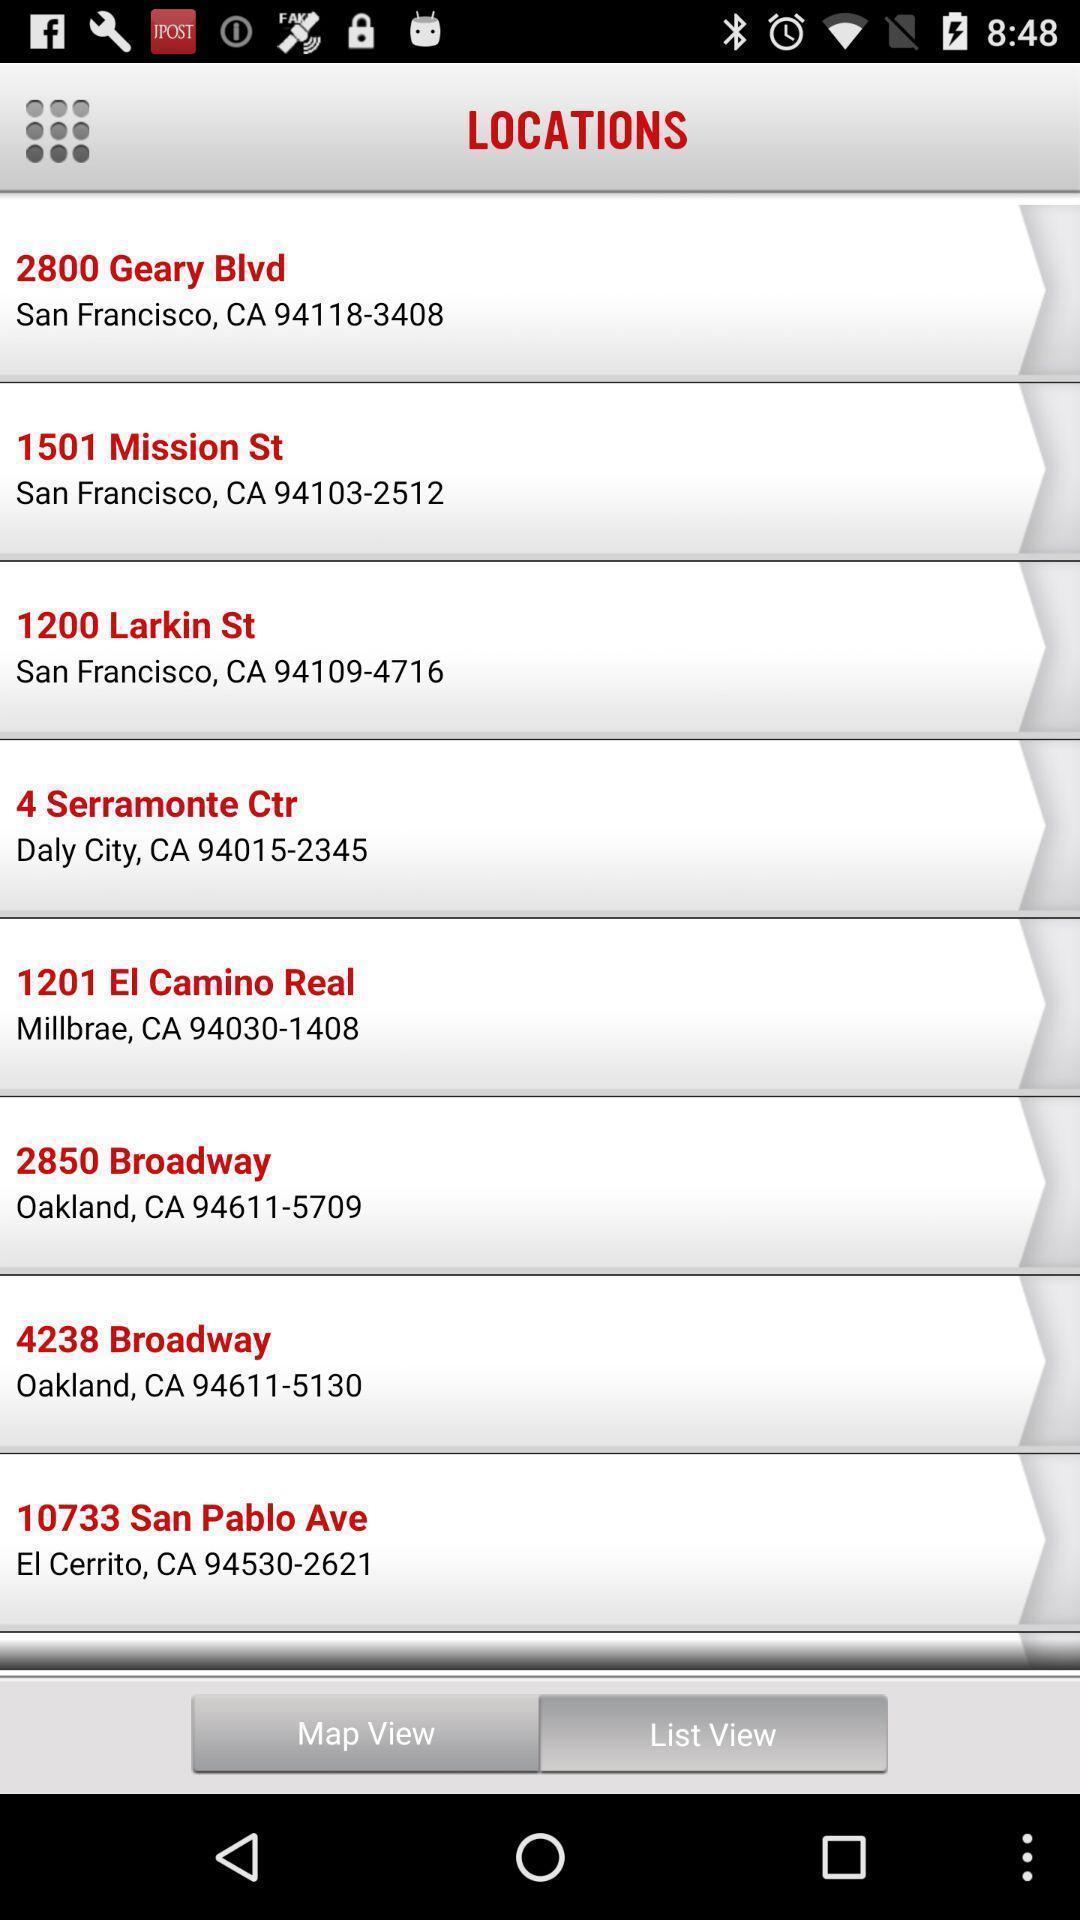Explain the elements present in this screenshot. Screen shows list of locations. 